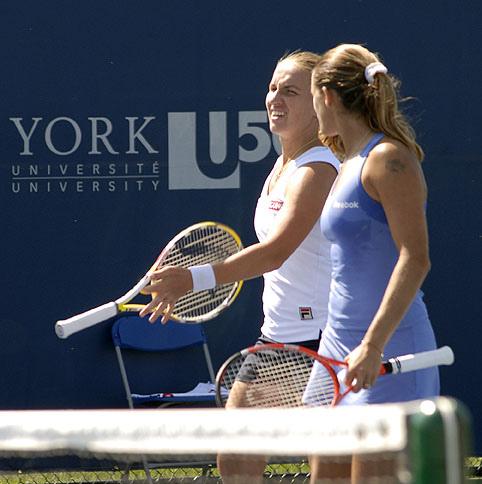Are these women in the middle of a match?
Keep it brief. No. What school is this?
Keep it brief. York. Who are the people playing?
Write a very short answer. Tennis. 